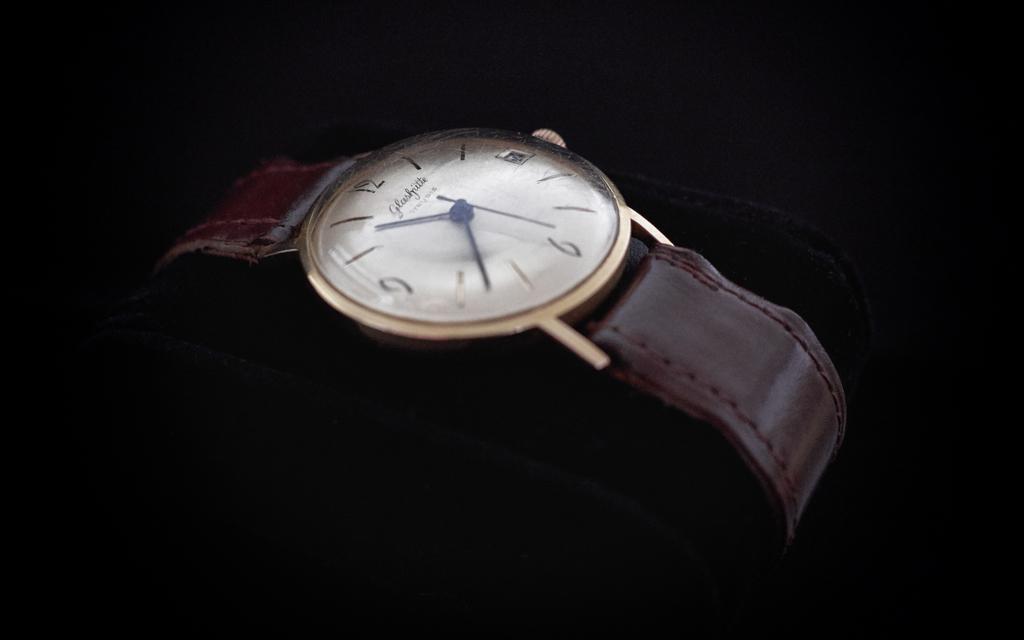Is it almost 11:45?
Your answer should be compact. No. 